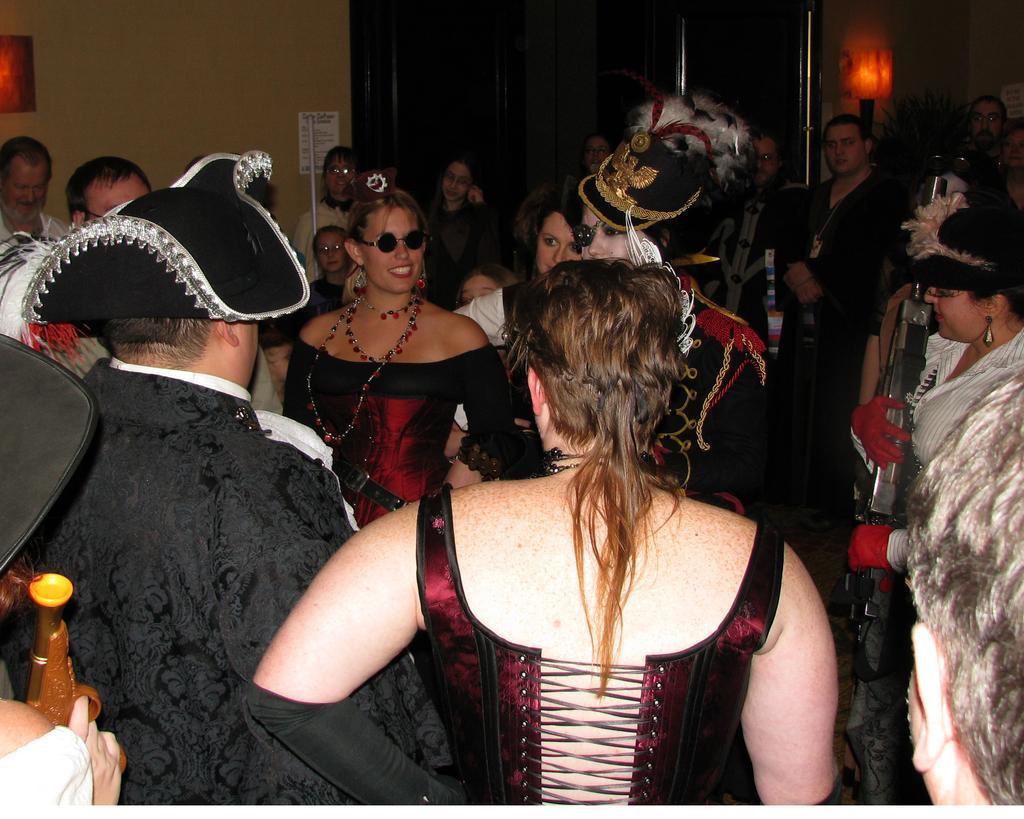How would you summarize this image in a sentence or two? As we can see in the image there are group of people here and there, hat, wall and poster. 